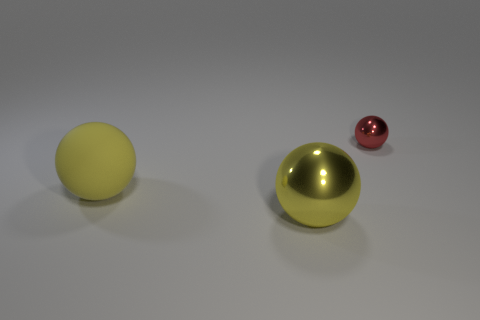The metallic object that is the same color as the large matte sphere is what size?
Provide a short and direct response. Large. What material is the yellow ball left of the yellow shiny thing?
Provide a succinct answer. Rubber. There is a ball that is both in front of the tiny red metallic ball and behind the large yellow metallic thing; what is its material?
Your answer should be very brief. Rubber. Do the big metal thing and the big rubber sphere have the same color?
Your answer should be compact. Yes. How many blocks are small metal things or metal objects?
Ensure brevity in your answer.  0. What shape is the thing that is in front of the rubber ball?
Your answer should be compact. Sphere. What number of other red spheres are the same material as the small sphere?
Your answer should be compact. 0. Is the number of tiny red metallic balls that are in front of the large metal sphere less than the number of big blue objects?
Give a very brief answer. No. What size is the sphere that is on the right side of the metallic object on the left side of the tiny red sphere?
Provide a succinct answer. Small. Is the color of the matte sphere the same as the shiny sphere that is to the left of the tiny red object?
Give a very brief answer. Yes. 